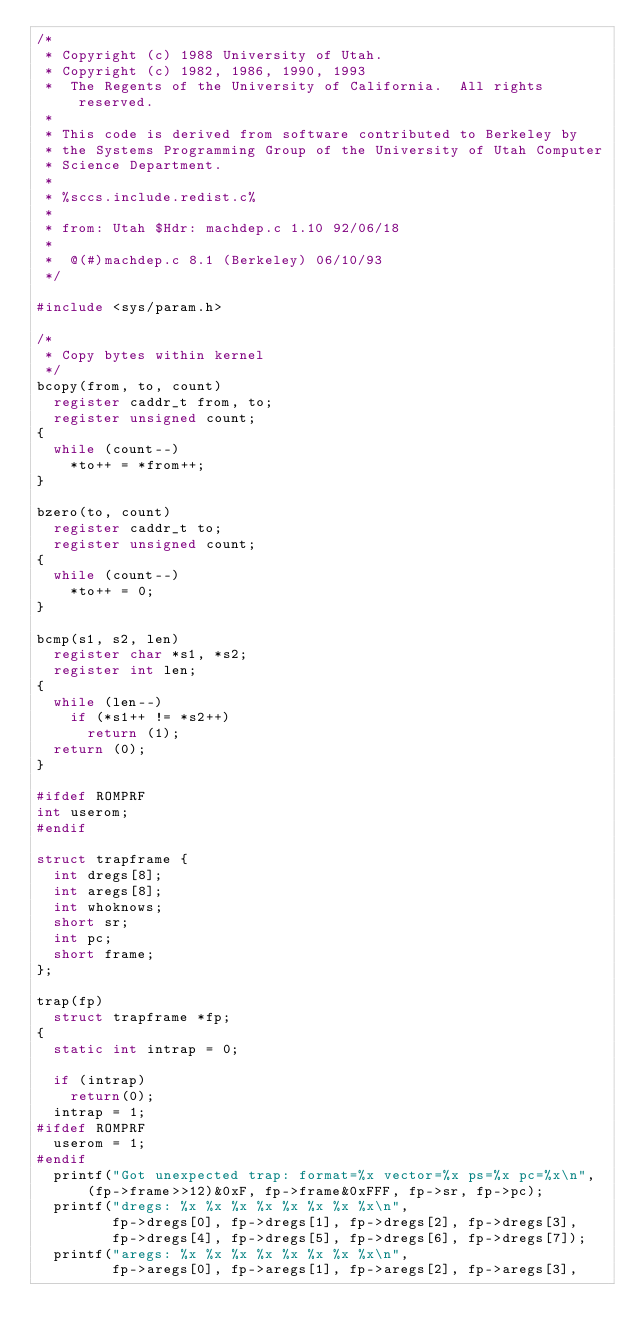<code> <loc_0><loc_0><loc_500><loc_500><_C_>/*
 * Copyright (c) 1988 University of Utah.
 * Copyright (c) 1982, 1986, 1990, 1993
 *	The Regents of the University of California.  All rights reserved.
 *
 * This code is derived from software contributed to Berkeley by
 * the Systems Programming Group of the University of Utah Computer
 * Science Department.
 *
 * %sccs.include.redist.c%
 *
 * from: Utah $Hdr: machdep.c 1.10 92/06/18
 *
 *	@(#)machdep.c	8.1 (Berkeley) 06/10/93
 */

#include <sys/param.h>

/*
 * Copy bytes within kernel
 */
bcopy(from, to, count)
	register caddr_t from, to;
	register unsigned count;
{
	while (count--)
		*to++ = *from++;
}

bzero(to, count)
	register caddr_t to;
	register unsigned count;
{
	while (count--)
		*to++ = 0;
}

bcmp(s1, s2, len)
	register char *s1, *s2;
	register int len;
{
	while (len--)
		if (*s1++ != *s2++)
			return (1);
	return (0);
}

#ifdef ROMPRF
int userom;
#endif

struct trapframe {
	int dregs[8];
	int aregs[8];
	int whoknows;
	short sr;
	int pc;
	short frame;
};

trap(fp)
	struct trapframe *fp;
{
	static int intrap = 0;

	if (intrap)
		return(0);
	intrap = 1;
#ifdef ROMPRF
	userom = 1;
#endif
	printf("Got unexpected trap: format=%x vector=%x ps=%x pc=%x\n",
		  (fp->frame>>12)&0xF, fp->frame&0xFFF, fp->sr, fp->pc);
	printf("dregs: %x %x %x %x %x %x %x %x\n",
	       fp->dregs[0], fp->dregs[1], fp->dregs[2], fp->dregs[3], 
	       fp->dregs[4], fp->dregs[5], fp->dregs[6], fp->dregs[7]);
	printf("aregs: %x %x %x %x %x %x %x %x\n",
	       fp->aregs[0], fp->aregs[1], fp->aregs[2], fp->aregs[3], </code> 